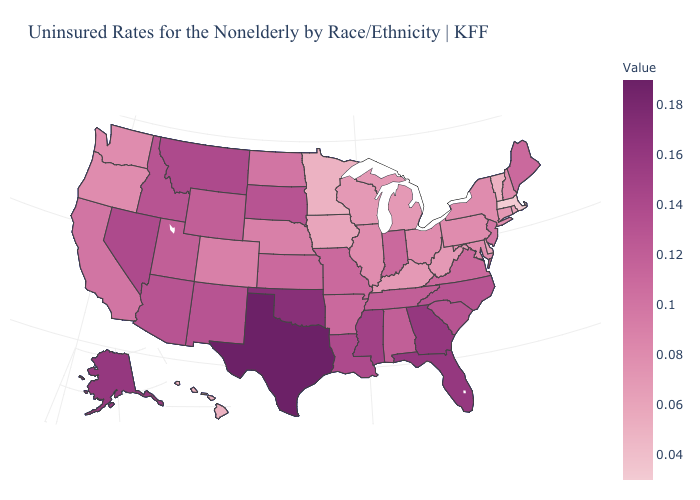Does the map have missing data?
Concise answer only. No. Which states have the lowest value in the USA?
Keep it brief. Massachusetts. Which states have the lowest value in the West?
Be succinct. Hawaii. Does Massachusetts have the lowest value in the USA?
Short answer required. Yes. 